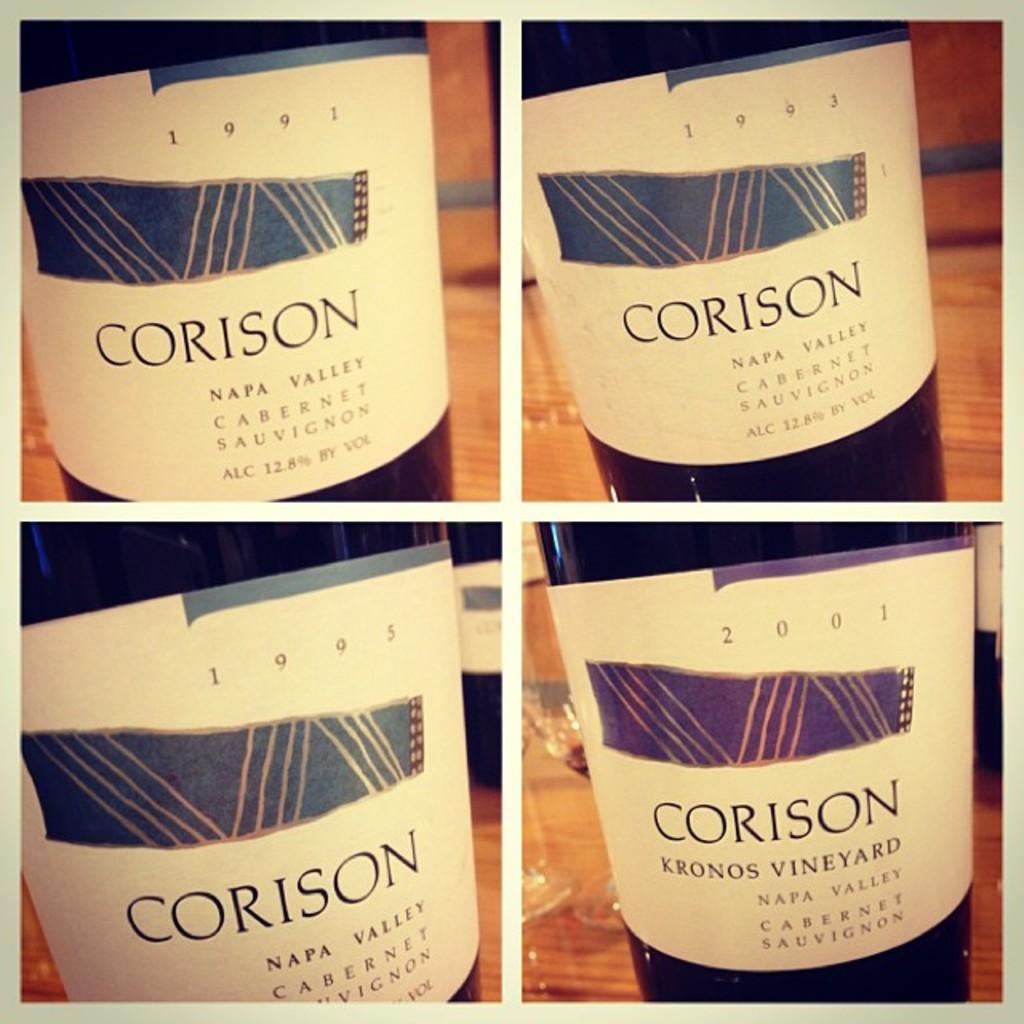<image>
Write a terse but informative summary of the picture. Four bottles of "CORISON" wine from Napa Valley are shown. 